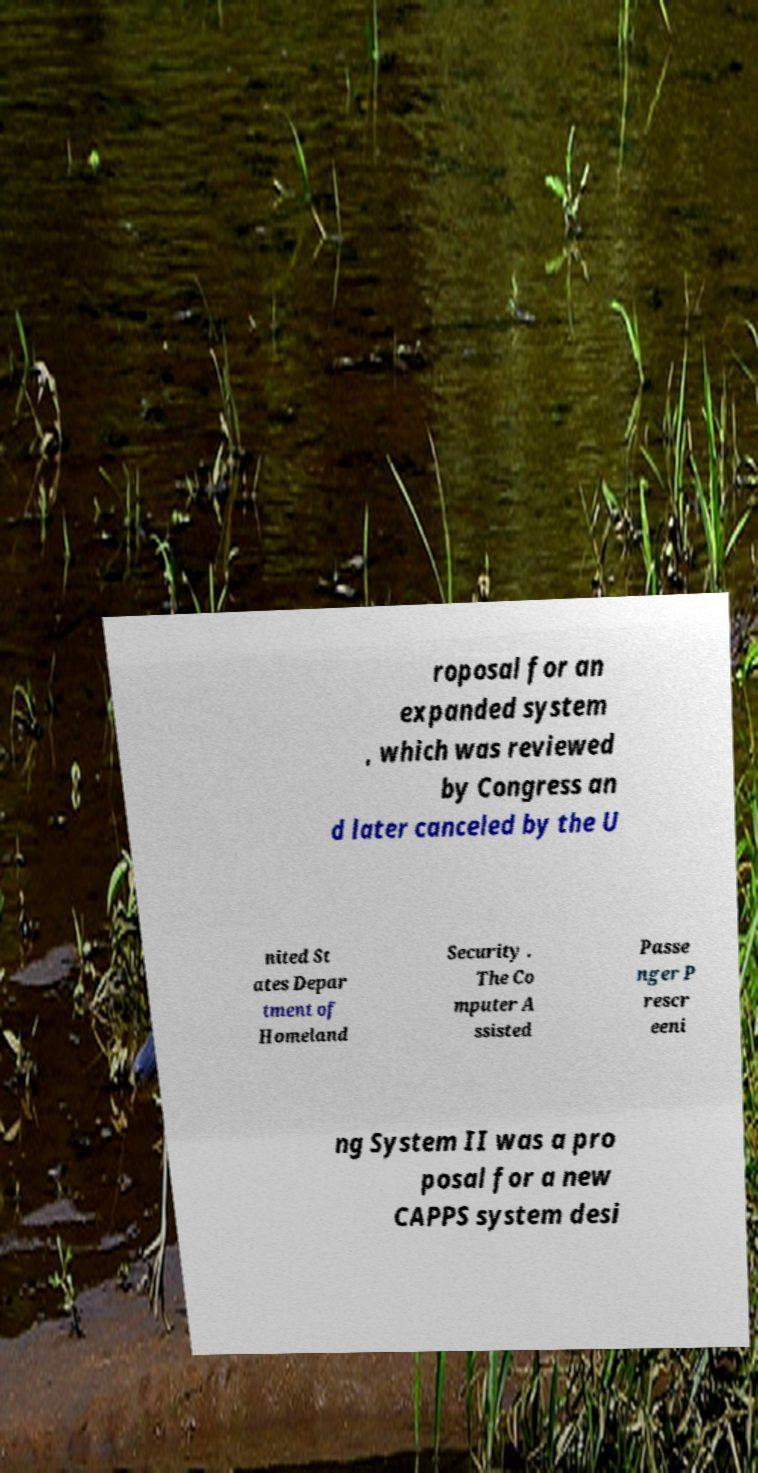Could you extract and type out the text from this image? roposal for an expanded system , which was reviewed by Congress an d later canceled by the U nited St ates Depar tment of Homeland Security . The Co mputer A ssisted Passe nger P rescr eeni ng System II was a pro posal for a new CAPPS system desi 